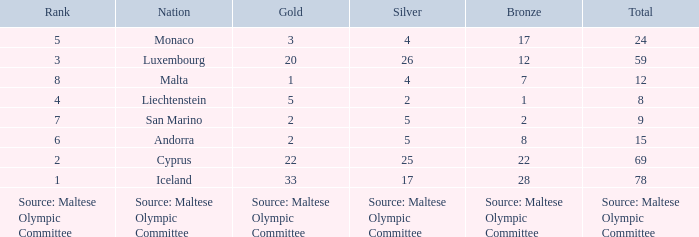What is the total medal count for the nation that has 5 gold? 8.0. 